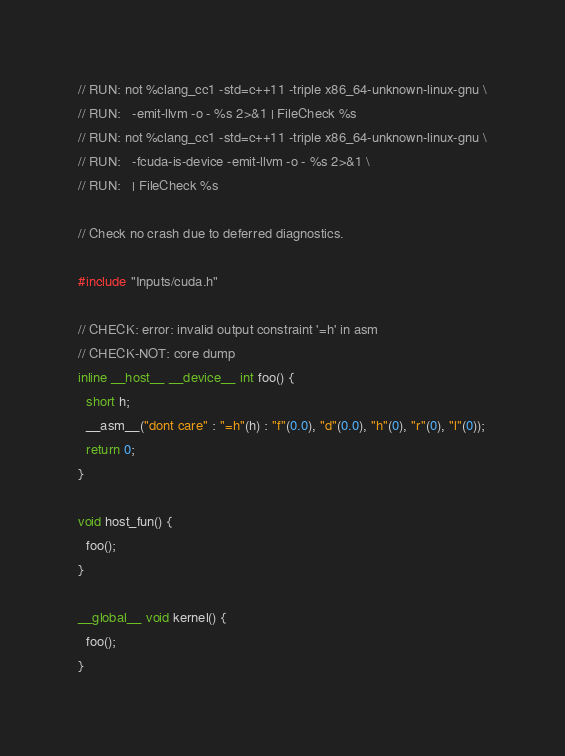Convert code to text. <code><loc_0><loc_0><loc_500><loc_500><_Cuda_>// RUN: not %clang_cc1 -std=c++11 -triple x86_64-unknown-linux-gnu \
// RUN:   -emit-llvm -o - %s 2>&1 | FileCheck %s
// RUN: not %clang_cc1 -std=c++11 -triple x86_64-unknown-linux-gnu \
// RUN:   -fcuda-is-device -emit-llvm -o - %s 2>&1 \
// RUN:   | FileCheck %s

// Check no crash due to deferred diagnostics.

#include "Inputs/cuda.h"

// CHECK: error: invalid output constraint '=h' in asm
// CHECK-NOT: core dump
inline __host__ __device__ int foo() {
  short h;
  __asm__("dont care" : "=h"(h) : "f"(0.0), "d"(0.0), "h"(0), "r"(0), "l"(0));
  return 0;
}

void host_fun() {
  foo();
}

__global__ void kernel() {
  foo();
}
</code> 